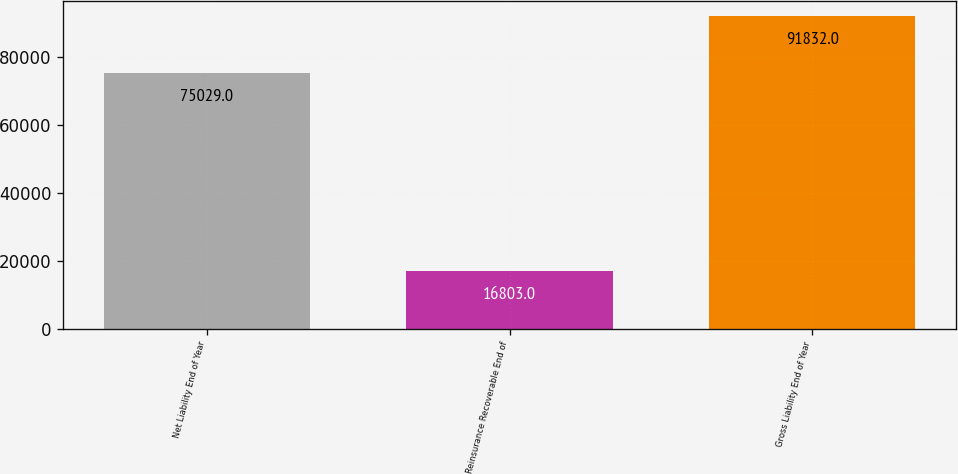Convert chart. <chart><loc_0><loc_0><loc_500><loc_500><bar_chart><fcel>Net Liability End of Year<fcel>Reinsurance Recoverable End of<fcel>Gross Liability End of Year<nl><fcel>75029<fcel>16803<fcel>91832<nl></chart> 